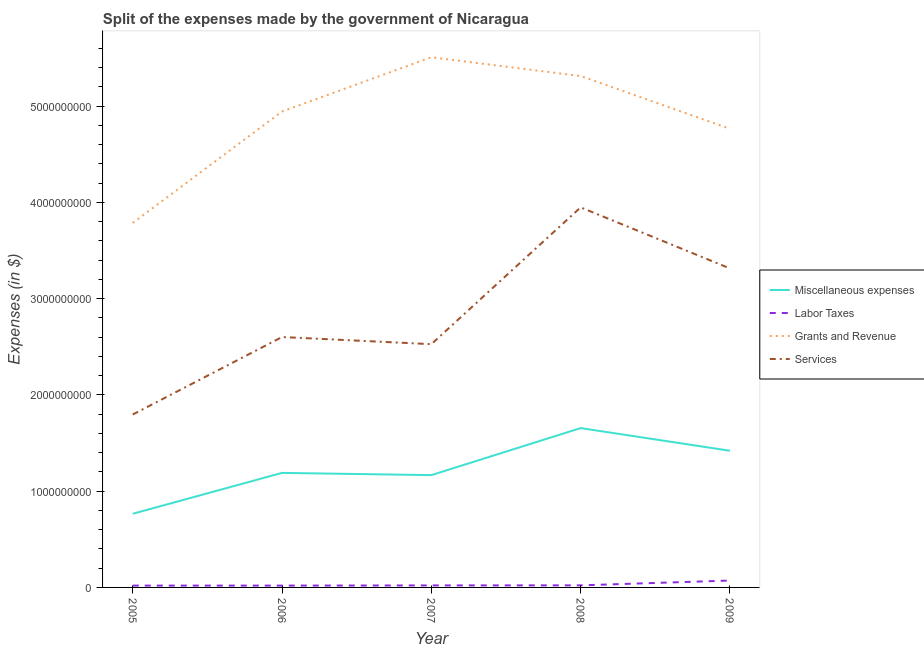How many different coloured lines are there?
Give a very brief answer. 4. What is the amount spent on labor taxes in 2006?
Your answer should be very brief. 1.90e+07. Across all years, what is the maximum amount spent on labor taxes?
Provide a succinct answer. 7.15e+07. Across all years, what is the minimum amount spent on grants and revenue?
Ensure brevity in your answer.  3.79e+09. In which year was the amount spent on miscellaneous expenses minimum?
Your response must be concise. 2005. What is the total amount spent on services in the graph?
Offer a very short reply. 1.42e+1. What is the difference between the amount spent on labor taxes in 2005 and that in 2007?
Your answer should be compact. -1.70e+06. What is the difference between the amount spent on services in 2009 and the amount spent on labor taxes in 2007?
Offer a terse response. 3.29e+09. What is the average amount spent on labor taxes per year?
Offer a terse response. 3.04e+07. In the year 2005, what is the difference between the amount spent on services and amount spent on labor taxes?
Ensure brevity in your answer.  1.78e+09. What is the ratio of the amount spent on labor taxes in 2007 to that in 2009?
Provide a succinct answer. 0.29. Is the amount spent on miscellaneous expenses in 2005 less than that in 2008?
Give a very brief answer. Yes. Is the difference between the amount spent on labor taxes in 2006 and 2007 greater than the difference between the amount spent on services in 2006 and 2007?
Provide a succinct answer. No. What is the difference between the highest and the second highest amount spent on miscellaneous expenses?
Your response must be concise. 2.35e+08. What is the difference between the highest and the lowest amount spent on miscellaneous expenses?
Your answer should be very brief. 8.90e+08. Is the sum of the amount spent on miscellaneous expenses in 2005 and 2007 greater than the maximum amount spent on services across all years?
Provide a succinct answer. No. Is it the case that in every year, the sum of the amount spent on labor taxes and amount spent on grants and revenue is greater than the sum of amount spent on miscellaneous expenses and amount spent on services?
Offer a very short reply. No. Is it the case that in every year, the sum of the amount spent on miscellaneous expenses and amount spent on labor taxes is greater than the amount spent on grants and revenue?
Provide a succinct answer. No. Does the amount spent on labor taxes monotonically increase over the years?
Give a very brief answer. No. How many lines are there?
Ensure brevity in your answer.  4. How many years are there in the graph?
Offer a terse response. 5. What is the difference between two consecutive major ticks on the Y-axis?
Offer a very short reply. 1.00e+09. Does the graph contain any zero values?
Offer a terse response. No. Does the graph contain grids?
Your response must be concise. No. How many legend labels are there?
Make the answer very short. 4. How are the legend labels stacked?
Offer a terse response. Vertical. What is the title of the graph?
Give a very brief answer. Split of the expenses made by the government of Nicaragua. Does "Korea" appear as one of the legend labels in the graph?
Your response must be concise. No. What is the label or title of the Y-axis?
Make the answer very short. Expenses (in $). What is the Expenses (in $) of Miscellaneous expenses in 2005?
Offer a terse response. 7.65e+08. What is the Expenses (in $) in Labor Taxes in 2005?
Your answer should be compact. 1.90e+07. What is the Expenses (in $) in Grants and Revenue in 2005?
Your answer should be very brief. 3.79e+09. What is the Expenses (in $) in Services in 2005?
Your answer should be very brief. 1.80e+09. What is the Expenses (in $) of Miscellaneous expenses in 2006?
Your answer should be compact. 1.19e+09. What is the Expenses (in $) of Labor Taxes in 2006?
Your answer should be compact. 1.90e+07. What is the Expenses (in $) of Grants and Revenue in 2006?
Keep it short and to the point. 4.94e+09. What is the Expenses (in $) of Services in 2006?
Offer a terse response. 2.60e+09. What is the Expenses (in $) in Miscellaneous expenses in 2007?
Offer a terse response. 1.17e+09. What is the Expenses (in $) of Labor Taxes in 2007?
Ensure brevity in your answer.  2.07e+07. What is the Expenses (in $) in Grants and Revenue in 2007?
Your answer should be compact. 5.51e+09. What is the Expenses (in $) of Services in 2007?
Offer a terse response. 2.53e+09. What is the Expenses (in $) of Miscellaneous expenses in 2008?
Your answer should be compact. 1.65e+09. What is the Expenses (in $) of Labor Taxes in 2008?
Offer a terse response. 2.16e+07. What is the Expenses (in $) in Grants and Revenue in 2008?
Your answer should be very brief. 5.31e+09. What is the Expenses (in $) of Services in 2008?
Your response must be concise. 3.95e+09. What is the Expenses (in $) of Miscellaneous expenses in 2009?
Ensure brevity in your answer.  1.42e+09. What is the Expenses (in $) in Labor Taxes in 2009?
Your response must be concise. 7.15e+07. What is the Expenses (in $) in Grants and Revenue in 2009?
Provide a short and direct response. 4.76e+09. What is the Expenses (in $) of Services in 2009?
Offer a very short reply. 3.31e+09. Across all years, what is the maximum Expenses (in $) in Miscellaneous expenses?
Make the answer very short. 1.65e+09. Across all years, what is the maximum Expenses (in $) of Labor Taxes?
Your response must be concise. 7.15e+07. Across all years, what is the maximum Expenses (in $) of Grants and Revenue?
Ensure brevity in your answer.  5.51e+09. Across all years, what is the maximum Expenses (in $) in Services?
Ensure brevity in your answer.  3.95e+09. Across all years, what is the minimum Expenses (in $) in Miscellaneous expenses?
Your answer should be very brief. 7.65e+08. Across all years, what is the minimum Expenses (in $) in Labor Taxes?
Ensure brevity in your answer.  1.90e+07. Across all years, what is the minimum Expenses (in $) in Grants and Revenue?
Provide a succinct answer. 3.79e+09. Across all years, what is the minimum Expenses (in $) in Services?
Provide a succinct answer. 1.80e+09. What is the total Expenses (in $) in Miscellaneous expenses in the graph?
Your answer should be compact. 6.20e+09. What is the total Expenses (in $) of Labor Taxes in the graph?
Ensure brevity in your answer.  1.52e+08. What is the total Expenses (in $) of Grants and Revenue in the graph?
Offer a terse response. 2.43e+1. What is the total Expenses (in $) in Services in the graph?
Provide a short and direct response. 1.42e+1. What is the difference between the Expenses (in $) of Miscellaneous expenses in 2005 and that in 2006?
Ensure brevity in your answer.  -4.25e+08. What is the difference between the Expenses (in $) of Labor Taxes in 2005 and that in 2006?
Provide a succinct answer. 0. What is the difference between the Expenses (in $) in Grants and Revenue in 2005 and that in 2006?
Provide a succinct answer. -1.16e+09. What is the difference between the Expenses (in $) in Services in 2005 and that in 2006?
Your answer should be compact. -8.05e+08. What is the difference between the Expenses (in $) of Miscellaneous expenses in 2005 and that in 2007?
Offer a very short reply. -4.01e+08. What is the difference between the Expenses (in $) of Labor Taxes in 2005 and that in 2007?
Offer a terse response. -1.70e+06. What is the difference between the Expenses (in $) of Grants and Revenue in 2005 and that in 2007?
Provide a short and direct response. -1.72e+09. What is the difference between the Expenses (in $) of Services in 2005 and that in 2007?
Your response must be concise. -7.31e+08. What is the difference between the Expenses (in $) of Miscellaneous expenses in 2005 and that in 2008?
Your answer should be very brief. -8.90e+08. What is the difference between the Expenses (in $) in Labor Taxes in 2005 and that in 2008?
Your answer should be very brief. -2.56e+06. What is the difference between the Expenses (in $) in Grants and Revenue in 2005 and that in 2008?
Provide a succinct answer. -1.53e+09. What is the difference between the Expenses (in $) of Services in 2005 and that in 2008?
Your answer should be compact. -2.15e+09. What is the difference between the Expenses (in $) of Miscellaneous expenses in 2005 and that in 2009?
Keep it short and to the point. -6.55e+08. What is the difference between the Expenses (in $) of Labor Taxes in 2005 and that in 2009?
Your answer should be compact. -5.25e+07. What is the difference between the Expenses (in $) in Grants and Revenue in 2005 and that in 2009?
Offer a very short reply. -9.78e+08. What is the difference between the Expenses (in $) of Services in 2005 and that in 2009?
Make the answer very short. -1.52e+09. What is the difference between the Expenses (in $) of Miscellaneous expenses in 2006 and that in 2007?
Your answer should be compact. 2.32e+07. What is the difference between the Expenses (in $) in Labor Taxes in 2006 and that in 2007?
Ensure brevity in your answer.  -1.70e+06. What is the difference between the Expenses (in $) in Grants and Revenue in 2006 and that in 2007?
Your response must be concise. -5.64e+08. What is the difference between the Expenses (in $) in Services in 2006 and that in 2007?
Offer a terse response. 7.43e+07. What is the difference between the Expenses (in $) of Miscellaneous expenses in 2006 and that in 2008?
Provide a short and direct response. -4.65e+08. What is the difference between the Expenses (in $) in Labor Taxes in 2006 and that in 2008?
Your answer should be compact. -2.56e+06. What is the difference between the Expenses (in $) of Grants and Revenue in 2006 and that in 2008?
Provide a succinct answer. -3.69e+08. What is the difference between the Expenses (in $) of Services in 2006 and that in 2008?
Your answer should be very brief. -1.35e+09. What is the difference between the Expenses (in $) of Miscellaneous expenses in 2006 and that in 2009?
Provide a short and direct response. -2.30e+08. What is the difference between the Expenses (in $) in Labor Taxes in 2006 and that in 2009?
Your response must be concise. -5.25e+07. What is the difference between the Expenses (in $) in Grants and Revenue in 2006 and that in 2009?
Keep it short and to the point. 1.79e+08. What is the difference between the Expenses (in $) in Services in 2006 and that in 2009?
Make the answer very short. -7.12e+08. What is the difference between the Expenses (in $) of Miscellaneous expenses in 2007 and that in 2008?
Ensure brevity in your answer.  -4.88e+08. What is the difference between the Expenses (in $) of Labor Taxes in 2007 and that in 2008?
Offer a terse response. -8.59e+05. What is the difference between the Expenses (in $) in Grants and Revenue in 2007 and that in 2008?
Provide a short and direct response. 1.95e+08. What is the difference between the Expenses (in $) in Services in 2007 and that in 2008?
Ensure brevity in your answer.  -1.42e+09. What is the difference between the Expenses (in $) of Miscellaneous expenses in 2007 and that in 2009?
Your answer should be compact. -2.53e+08. What is the difference between the Expenses (in $) in Labor Taxes in 2007 and that in 2009?
Provide a succinct answer. -5.08e+07. What is the difference between the Expenses (in $) of Grants and Revenue in 2007 and that in 2009?
Offer a very short reply. 7.43e+08. What is the difference between the Expenses (in $) of Services in 2007 and that in 2009?
Provide a short and direct response. -7.87e+08. What is the difference between the Expenses (in $) in Miscellaneous expenses in 2008 and that in 2009?
Provide a short and direct response. 2.35e+08. What is the difference between the Expenses (in $) of Labor Taxes in 2008 and that in 2009?
Make the answer very short. -4.99e+07. What is the difference between the Expenses (in $) of Grants and Revenue in 2008 and that in 2009?
Keep it short and to the point. 5.48e+08. What is the difference between the Expenses (in $) in Services in 2008 and that in 2009?
Provide a succinct answer. 6.34e+08. What is the difference between the Expenses (in $) in Miscellaneous expenses in 2005 and the Expenses (in $) in Labor Taxes in 2006?
Ensure brevity in your answer.  7.46e+08. What is the difference between the Expenses (in $) in Miscellaneous expenses in 2005 and the Expenses (in $) in Grants and Revenue in 2006?
Your response must be concise. -4.18e+09. What is the difference between the Expenses (in $) in Miscellaneous expenses in 2005 and the Expenses (in $) in Services in 2006?
Provide a short and direct response. -1.84e+09. What is the difference between the Expenses (in $) of Labor Taxes in 2005 and the Expenses (in $) of Grants and Revenue in 2006?
Keep it short and to the point. -4.92e+09. What is the difference between the Expenses (in $) in Labor Taxes in 2005 and the Expenses (in $) in Services in 2006?
Your response must be concise. -2.58e+09. What is the difference between the Expenses (in $) in Grants and Revenue in 2005 and the Expenses (in $) in Services in 2006?
Provide a short and direct response. 1.19e+09. What is the difference between the Expenses (in $) of Miscellaneous expenses in 2005 and the Expenses (in $) of Labor Taxes in 2007?
Your answer should be very brief. 7.44e+08. What is the difference between the Expenses (in $) in Miscellaneous expenses in 2005 and the Expenses (in $) in Grants and Revenue in 2007?
Ensure brevity in your answer.  -4.74e+09. What is the difference between the Expenses (in $) of Miscellaneous expenses in 2005 and the Expenses (in $) of Services in 2007?
Keep it short and to the point. -1.76e+09. What is the difference between the Expenses (in $) in Labor Taxes in 2005 and the Expenses (in $) in Grants and Revenue in 2007?
Offer a terse response. -5.49e+09. What is the difference between the Expenses (in $) in Labor Taxes in 2005 and the Expenses (in $) in Services in 2007?
Make the answer very short. -2.51e+09. What is the difference between the Expenses (in $) in Grants and Revenue in 2005 and the Expenses (in $) in Services in 2007?
Provide a succinct answer. 1.26e+09. What is the difference between the Expenses (in $) of Miscellaneous expenses in 2005 and the Expenses (in $) of Labor Taxes in 2008?
Your answer should be compact. 7.43e+08. What is the difference between the Expenses (in $) of Miscellaneous expenses in 2005 and the Expenses (in $) of Grants and Revenue in 2008?
Keep it short and to the point. -4.55e+09. What is the difference between the Expenses (in $) in Miscellaneous expenses in 2005 and the Expenses (in $) in Services in 2008?
Ensure brevity in your answer.  -3.18e+09. What is the difference between the Expenses (in $) of Labor Taxes in 2005 and the Expenses (in $) of Grants and Revenue in 2008?
Your response must be concise. -5.29e+09. What is the difference between the Expenses (in $) in Labor Taxes in 2005 and the Expenses (in $) in Services in 2008?
Offer a very short reply. -3.93e+09. What is the difference between the Expenses (in $) in Grants and Revenue in 2005 and the Expenses (in $) in Services in 2008?
Give a very brief answer. -1.62e+08. What is the difference between the Expenses (in $) of Miscellaneous expenses in 2005 and the Expenses (in $) of Labor Taxes in 2009?
Provide a succinct answer. 6.93e+08. What is the difference between the Expenses (in $) of Miscellaneous expenses in 2005 and the Expenses (in $) of Grants and Revenue in 2009?
Your answer should be very brief. -4.00e+09. What is the difference between the Expenses (in $) in Miscellaneous expenses in 2005 and the Expenses (in $) in Services in 2009?
Offer a terse response. -2.55e+09. What is the difference between the Expenses (in $) in Labor Taxes in 2005 and the Expenses (in $) in Grants and Revenue in 2009?
Give a very brief answer. -4.74e+09. What is the difference between the Expenses (in $) in Labor Taxes in 2005 and the Expenses (in $) in Services in 2009?
Make the answer very short. -3.29e+09. What is the difference between the Expenses (in $) of Grants and Revenue in 2005 and the Expenses (in $) of Services in 2009?
Your answer should be compact. 4.73e+08. What is the difference between the Expenses (in $) of Miscellaneous expenses in 2006 and the Expenses (in $) of Labor Taxes in 2007?
Provide a short and direct response. 1.17e+09. What is the difference between the Expenses (in $) of Miscellaneous expenses in 2006 and the Expenses (in $) of Grants and Revenue in 2007?
Keep it short and to the point. -4.32e+09. What is the difference between the Expenses (in $) in Miscellaneous expenses in 2006 and the Expenses (in $) in Services in 2007?
Make the answer very short. -1.34e+09. What is the difference between the Expenses (in $) in Labor Taxes in 2006 and the Expenses (in $) in Grants and Revenue in 2007?
Keep it short and to the point. -5.49e+09. What is the difference between the Expenses (in $) of Labor Taxes in 2006 and the Expenses (in $) of Services in 2007?
Make the answer very short. -2.51e+09. What is the difference between the Expenses (in $) in Grants and Revenue in 2006 and the Expenses (in $) in Services in 2007?
Offer a terse response. 2.42e+09. What is the difference between the Expenses (in $) of Miscellaneous expenses in 2006 and the Expenses (in $) of Labor Taxes in 2008?
Your answer should be very brief. 1.17e+09. What is the difference between the Expenses (in $) of Miscellaneous expenses in 2006 and the Expenses (in $) of Grants and Revenue in 2008?
Offer a terse response. -4.12e+09. What is the difference between the Expenses (in $) of Miscellaneous expenses in 2006 and the Expenses (in $) of Services in 2008?
Provide a short and direct response. -2.76e+09. What is the difference between the Expenses (in $) in Labor Taxes in 2006 and the Expenses (in $) in Grants and Revenue in 2008?
Provide a succinct answer. -5.29e+09. What is the difference between the Expenses (in $) in Labor Taxes in 2006 and the Expenses (in $) in Services in 2008?
Offer a terse response. -3.93e+09. What is the difference between the Expenses (in $) of Grants and Revenue in 2006 and the Expenses (in $) of Services in 2008?
Offer a very short reply. 9.95e+08. What is the difference between the Expenses (in $) in Miscellaneous expenses in 2006 and the Expenses (in $) in Labor Taxes in 2009?
Provide a succinct answer. 1.12e+09. What is the difference between the Expenses (in $) in Miscellaneous expenses in 2006 and the Expenses (in $) in Grants and Revenue in 2009?
Your answer should be compact. -3.57e+09. What is the difference between the Expenses (in $) in Miscellaneous expenses in 2006 and the Expenses (in $) in Services in 2009?
Make the answer very short. -2.12e+09. What is the difference between the Expenses (in $) of Labor Taxes in 2006 and the Expenses (in $) of Grants and Revenue in 2009?
Keep it short and to the point. -4.74e+09. What is the difference between the Expenses (in $) of Labor Taxes in 2006 and the Expenses (in $) of Services in 2009?
Provide a succinct answer. -3.29e+09. What is the difference between the Expenses (in $) of Grants and Revenue in 2006 and the Expenses (in $) of Services in 2009?
Keep it short and to the point. 1.63e+09. What is the difference between the Expenses (in $) in Miscellaneous expenses in 2007 and the Expenses (in $) in Labor Taxes in 2008?
Provide a succinct answer. 1.14e+09. What is the difference between the Expenses (in $) in Miscellaneous expenses in 2007 and the Expenses (in $) in Grants and Revenue in 2008?
Your answer should be very brief. -4.15e+09. What is the difference between the Expenses (in $) of Miscellaneous expenses in 2007 and the Expenses (in $) of Services in 2008?
Provide a succinct answer. -2.78e+09. What is the difference between the Expenses (in $) of Labor Taxes in 2007 and the Expenses (in $) of Grants and Revenue in 2008?
Give a very brief answer. -5.29e+09. What is the difference between the Expenses (in $) in Labor Taxes in 2007 and the Expenses (in $) in Services in 2008?
Ensure brevity in your answer.  -3.93e+09. What is the difference between the Expenses (in $) in Grants and Revenue in 2007 and the Expenses (in $) in Services in 2008?
Offer a very short reply. 1.56e+09. What is the difference between the Expenses (in $) in Miscellaneous expenses in 2007 and the Expenses (in $) in Labor Taxes in 2009?
Ensure brevity in your answer.  1.09e+09. What is the difference between the Expenses (in $) of Miscellaneous expenses in 2007 and the Expenses (in $) of Grants and Revenue in 2009?
Provide a succinct answer. -3.60e+09. What is the difference between the Expenses (in $) of Miscellaneous expenses in 2007 and the Expenses (in $) of Services in 2009?
Provide a succinct answer. -2.15e+09. What is the difference between the Expenses (in $) in Labor Taxes in 2007 and the Expenses (in $) in Grants and Revenue in 2009?
Your answer should be compact. -4.74e+09. What is the difference between the Expenses (in $) in Labor Taxes in 2007 and the Expenses (in $) in Services in 2009?
Provide a short and direct response. -3.29e+09. What is the difference between the Expenses (in $) in Grants and Revenue in 2007 and the Expenses (in $) in Services in 2009?
Offer a very short reply. 2.19e+09. What is the difference between the Expenses (in $) of Miscellaneous expenses in 2008 and the Expenses (in $) of Labor Taxes in 2009?
Keep it short and to the point. 1.58e+09. What is the difference between the Expenses (in $) of Miscellaneous expenses in 2008 and the Expenses (in $) of Grants and Revenue in 2009?
Offer a very short reply. -3.11e+09. What is the difference between the Expenses (in $) of Miscellaneous expenses in 2008 and the Expenses (in $) of Services in 2009?
Your answer should be very brief. -1.66e+09. What is the difference between the Expenses (in $) of Labor Taxes in 2008 and the Expenses (in $) of Grants and Revenue in 2009?
Offer a terse response. -4.74e+09. What is the difference between the Expenses (in $) of Labor Taxes in 2008 and the Expenses (in $) of Services in 2009?
Give a very brief answer. -3.29e+09. What is the difference between the Expenses (in $) of Grants and Revenue in 2008 and the Expenses (in $) of Services in 2009?
Your answer should be compact. 2.00e+09. What is the average Expenses (in $) in Miscellaneous expenses per year?
Keep it short and to the point. 1.24e+09. What is the average Expenses (in $) in Labor Taxes per year?
Your response must be concise. 3.04e+07. What is the average Expenses (in $) in Grants and Revenue per year?
Offer a very short reply. 4.86e+09. What is the average Expenses (in $) of Services per year?
Make the answer very short. 2.84e+09. In the year 2005, what is the difference between the Expenses (in $) in Miscellaneous expenses and Expenses (in $) in Labor Taxes?
Provide a short and direct response. 7.46e+08. In the year 2005, what is the difference between the Expenses (in $) of Miscellaneous expenses and Expenses (in $) of Grants and Revenue?
Offer a terse response. -3.02e+09. In the year 2005, what is the difference between the Expenses (in $) in Miscellaneous expenses and Expenses (in $) in Services?
Keep it short and to the point. -1.03e+09. In the year 2005, what is the difference between the Expenses (in $) in Labor Taxes and Expenses (in $) in Grants and Revenue?
Your answer should be very brief. -3.77e+09. In the year 2005, what is the difference between the Expenses (in $) in Labor Taxes and Expenses (in $) in Services?
Keep it short and to the point. -1.78e+09. In the year 2005, what is the difference between the Expenses (in $) of Grants and Revenue and Expenses (in $) of Services?
Your response must be concise. 1.99e+09. In the year 2006, what is the difference between the Expenses (in $) of Miscellaneous expenses and Expenses (in $) of Labor Taxes?
Make the answer very short. 1.17e+09. In the year 2006, what is the difference between the Expenses (in $) in Miscellaneous expenses and Expenses (in $) in Grants and Revenue?
Provide a short and direct response. -3.75e+09. In the year 2006, what is the difference between the Expenses (in $) of Miscellaneous expenses and Expenses (in $) of Services?
Offer a terse response. -1.41e+09. In the year 2006, what is the difference between the Expenses (in $) in Labor Taxes and Expenses (in $) in Grants and Revenue?
Your answer should be very brief. -4.92e+09. In the year 2006, what is the difference between the Expenses (in $) in Labor Taxes and Expenses (in $) in Services?
Give a very brief answer. -2.58e+09. In the year 2006, what is the difference between the Expenses (in $) in Grants and Revenue and Expenses (in $) in Services?
Keep it short and to the point. 2.34e+09. In the year 2007, what is the difference between the Expenses (in $) of Miscellaneous expenses and Expenses (in $) of Labor Taxes?
Your answer should be very brief. 1.15e+09. In the year 2007, what is the difference between the Expenses (in $) in Miscellaneous expenses and Expenses (in $) in Grants and Revenue?
Your answer should be compact. -4.34e+09. In the year 2007, what is the difference between the Expenses (in $) of Miscellaneous expenses and Expenses (in $) of Services?
Keep it short and to the point. -1.36e+09. In the year 2007, what is the difference between the Expenses (in $) in Labor Taxes and Expenses (in $) in Grants and Revenue?
Offer a terse response. -5.49e+09. In the year 2007, what is the difference between the Expenses (in $) in Labor Taxes and Expenses (in $) in Services?
Give a very brief answer. -2.51e+09. In the year 2007, what is the difference between the Expenses (in $) in Grants and Revenue and Expenses (in $) in Services?
Make the answer very short. 2.98e+09. In the year 2008, what is the difference between the Expenses (in $) of Miscellaneous expenses and Expenses (in $) of Labor Taxes?
Your answer should be compact. 1.63e+09. In the year 2008, what is the difference between the Expenses (in $) of Miscellaneous expenses and Expenses (in $) of Grants and Revenue?
Keep it short and to the point. -3.66e+09. In the year 2008, what is the difference between the Expenses (in $) of Miscellaneous expenses and Expenses (in $) of Services?
Your response must be concise. -2.29e+09. In the year 2008, what is the difference between the Expenses (in $) of Labor Taxes and Expenses (in $) of Grants and Revenue?
Provide a short and direct response. -5.29e+09. In the year 2008, what is the difference between the Expenses (in $) of Labor Taxes and Expenses (in $) of Services?
Offer a very short reply. -3.93e+09. In the year 2008, what is the difference between the Expenses (in $) in Grants and Revenue and Expenses (in $) in Services?
Provide a succinct answer. 1.36e+09. In the year 2009, what is the difference between the Expenses (in $) of Miscellaneous expenses and Expenses (in $) of Labor Taxes?
Provide a succinct answer. 1.35e+09. In the year 2009, what is the difference between the Expenses (in $) in Miscellaneous expenses and Expenses (in $) in Grants and Revenue?
Ensure brevity in your answer.  -3.34e+09. In the year 2009, what is the difference between the Expenses (in $) of Miscellaneous expenses and Expenses (in $) of Services?
Your response must be concise. -1.89e+09. In the year 2009, what is the difference between the Expenses (in $) in Labor Taxes and Expenses (in $) in Grants and Revenue?
Provide a succinct answer. -4.69e+09. In the year 2009, what is the difference between the Expenses (in $) in Labor Taxes and Expenses (in $) in Services?
Your answer should be compact. -3.24e+09. In the year 2009, what is the difference between the Expenses (in $) of Grants and Revenue and Expenses (in $) of Services?
Provide a succinct answer. 1.45e+09. What is the ratio of the Expenses (in $) of Miscellaneous expenses in 2005 to that in 2006?
Your answer should be very brief. 0.64. What is the ratio of the Expenses (in $) of Grants and Revenue in 2005 to that in 2006?
Your answer should be very brief. 0.77. What is the ratio of the Expenses (in $) of Services in 2005 to that in 2006?
Offer a terse response. 0.69. What is the ratio of the Expenses (in $) in Miscellaneous expenses in 2005 to that in 2007?
Offer a very short reply. 0.66. What is the ratio of the Expenses (in $) of Labor Taxes in 2005 to that in 2007?
Your answer should be very brief. 0.92. What is the ratio of the Expenses (in $) in Grants and Revenue in 2005 to that in 2007?
Make the answer very short. 0.69. What is the ratio of the Expenses (in $) of Services in 2005 to that in 2007?
Ensure brevity in your answer.  0.71. What is the ratio of the Expenses (in $) in Miscellaneous expenses in 2005 to that in 2008?
Offer a very short reply. 0.46. What is the ratio of the Expenses (in $) of Labor Taxes in 2005 to that in 2008?
Make the answer very short. 0.88. What is the ratio of the Expenses (in $) in Grants and Revenue in 2005 to that in 2008?
Make the answer very short. 0.71. What is the ratio of the Expenses (in $) in Services in 2005 to that in 2008?
Provide a succinct answer. 0.46. What is the ratio of the Expenses (in $) in Miscellaneous expenses in 2005 to that in 2009?
Ensure brevity in your answer.  0.54. What is the ratio of the Expenses (in $) of Labor Taxes in 2005 to that in 2009?
Provide a short and direct response. 0.27. What is the ratio of the Expenses (in $) in Grants and Revenue in 2005 to that in 2009?
Make the answer very short. 0.79. What is the ratio of the Expenses (in $) of Services in 2005 to that in 2009?
Give a very brief answer. 0.54. What is the ratio of the Expenses (in $) of Miscellaneous expenses in 2006 to that in 2007?
Your answer should be very brief. 1.02. What is the ratio of the Expenses (in $) of Labor Taxes in 2006 to that in 2007?
Your response must be concise. 0.92. What is the ratio of the Expenses (in $) in Grants and Revenue in 2006 to that in 2007?
Provide a short and direct response. 0.9. What is the ratio of the Expenses (in $) in Services in 2006 to that in 2007?
Provide a succinct answer. 1.03. What is the ratio of the Expenses (in $) of Miscellaneous expenses in 2006 to that in 2008?
Offer a very short reply. 0.72. What is the ratio of the Expenses (in $) of Labor Taxes in 2006 to that in 2008?
Offer a very short reply. 0.88. What is the ratio of the Expenses (in $) in Grants and Revenue in 2006 to that in 2008?
Give a very brief answer. 0.93. What is the ratio of the Expenses (in $) of Services in 2006 to that in 2008?
Your answer should be compact. 0.66. What is the ratio of the Expenses (in $) in Miscellaneous expenses in 2006 to that in 2009?
Your answer should be very brief. 0.84. What is the ratio of the Expenses (in $) in Labor Taxes in 2006 to that in 2009?
Provide a succinct answer. 0.27. What is the ratio of the Expenses (in $) in Grants and Revenue in 2006 to that in 2009?
Give a very brief answer. 1.04. What is the ratio of the Expenses (in $) of Services in 2006 to that in 2009?
Your answer should be compact. 0.79. What is the ratio of the Expenses (in $) in Miscellaneous expenses in 2007 to that in 2008?
Offer a very short reply. 0.7. What is the ratio of the Expenses (in $) of Labor Taxes in 2007 to that in 2008?
Offer a very short reply. 0.96. What is the ratio of the Expenses (in $) of Grants and Revenue in 2007 to that in 2008?
Your answer should be compact. 1.04. What is the ratio of the Expenses (in $) in Services in 2007 to that in 2008?
Provide a short and direct response. 0.64. What is the ratio of the Expenses (in $) of Miscellaneous expenses in 2007 to that in 2009?
Offer a very short reply. 0.82. What is the ratio of the Expenses (in $) in Labor Taxes in 2007 to that in 2009?
Offer a terse response. 0.29. What is the ratio of the Expenses (in $) in Grants and Revenue in 2007 to that in 2009?
Your answer should be very brief. 1.16. What is the ratio of the Expenses (in $) in Services in 2007 to that in 2009?
Offer a terse response. 0.76. What is the ratio of the Expenses (in $) of Miscellaneous expenses in 2008 to that in 2009?
Give a very brief answer. 1.17. What is the ratio of the Expenses (in $) of Labor Taxes in 2008 to that in 2009?
Give a very brief answer. 0.3. What is the ratio of the Expenses (in $) of Grants and Revenue in 2008 to that in 2009?
Provide a succinct answer. 1.12. What is the ratio of the Expenses (in $) of Services in 2008 to that in 2009?
Offer a terse response. 1.19. What is the difference between the highest and the second highest Expenses (in $) in Miscellaneous expenses?
Offer a terse response. 2.35e+08. What is the difference between the highest and the second highest Expenses (in $) in Labor Taxes?
Your answer should be very brief. 4.99e+07. What is the difference between the highest and the second highest Expenses (in $) of Grants and Revenue?
Offer a very short reply. 1.95e+08. What is the difference between the highest and the second highest Expenses (in $) of Services?
Make the answer very short. 6.34e+08. What is the difference between the highest and the lowest Expenses (in $) of Miscellaneous expenses?
Ensure brevity in your answer.  8.90e+08. What is the difference between the highest and the lowest Expenses (in $) in Labor Taxes?
Keep it short and to the point. 5.25e+07. What is the difference between the highest and the lowest Expenses (in $) of Grants and Revenue?
Your answer should be very brief. 1.72e+09. What is the difference between the highest and the lowest Expenses (in $) in Services?
Your answer should be very brief. 2.15e+09. 